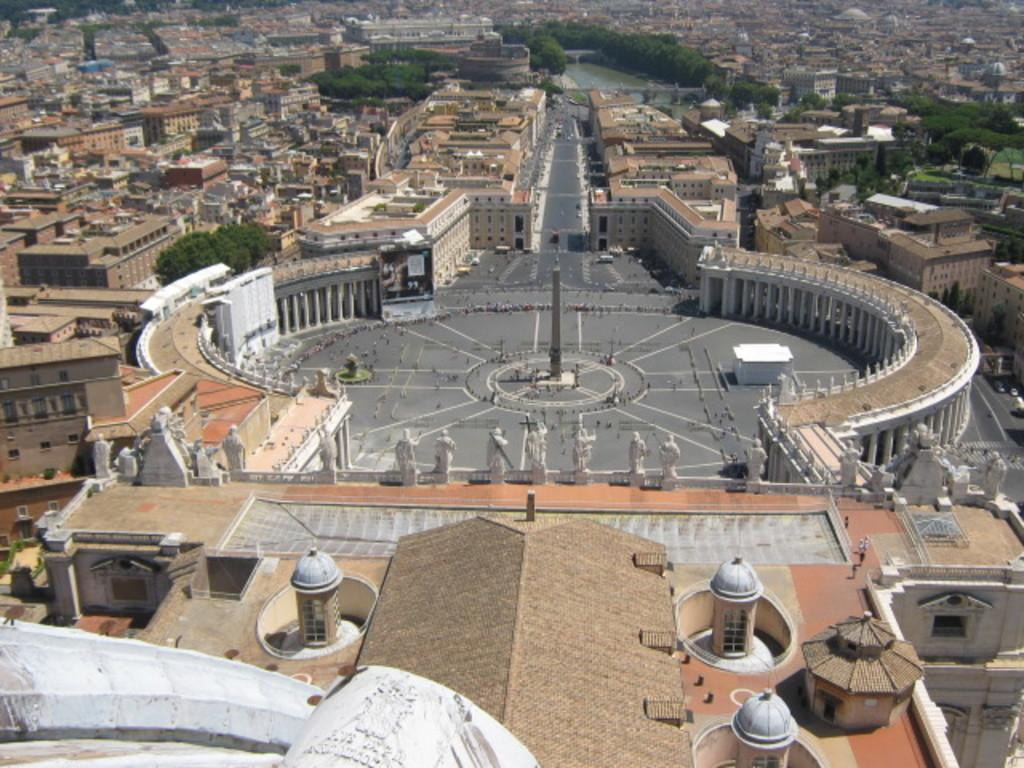What type of structures can be seen in the image? There is a group of buildings in the image. What natural element is visible in the image? There is water visible in the image. What type of vegetation is present in the image? There are trees in the image. What hobbies are being advertised on the billboard in the image? There is no billboard or advertisement present in the image. 